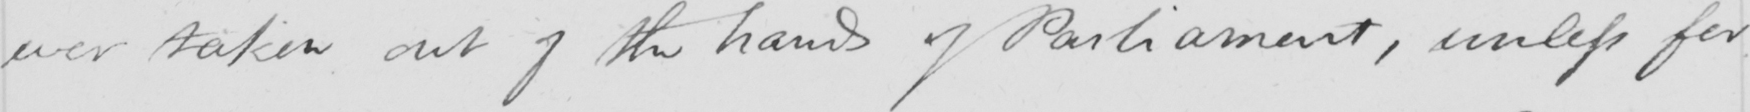What does this handwritten line say? ever taken out of the hands of Parliament, unless for 